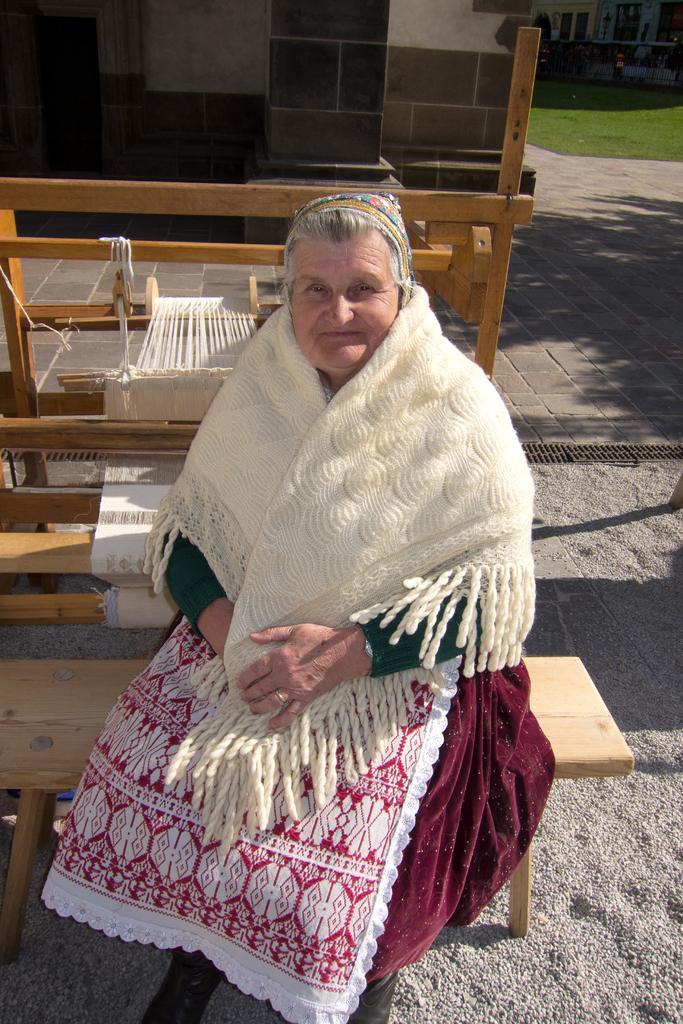Please provide a concise description of this image. In the image in the center,we can see one woman sitting on the bench and she is smiling,which we can see on her face. In the background there is a wall,woods,grass etc. 